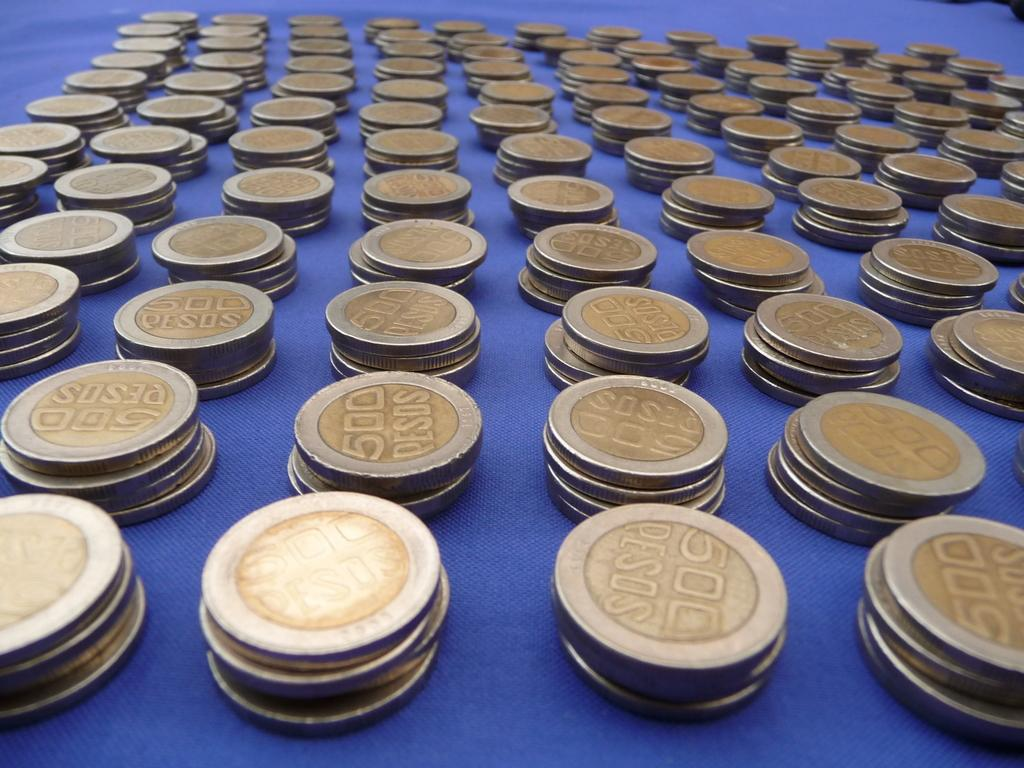<image>
Relay a brief, clear account of the picture shown. 500 pesos on silver and gold coins stacked on top of each other. 